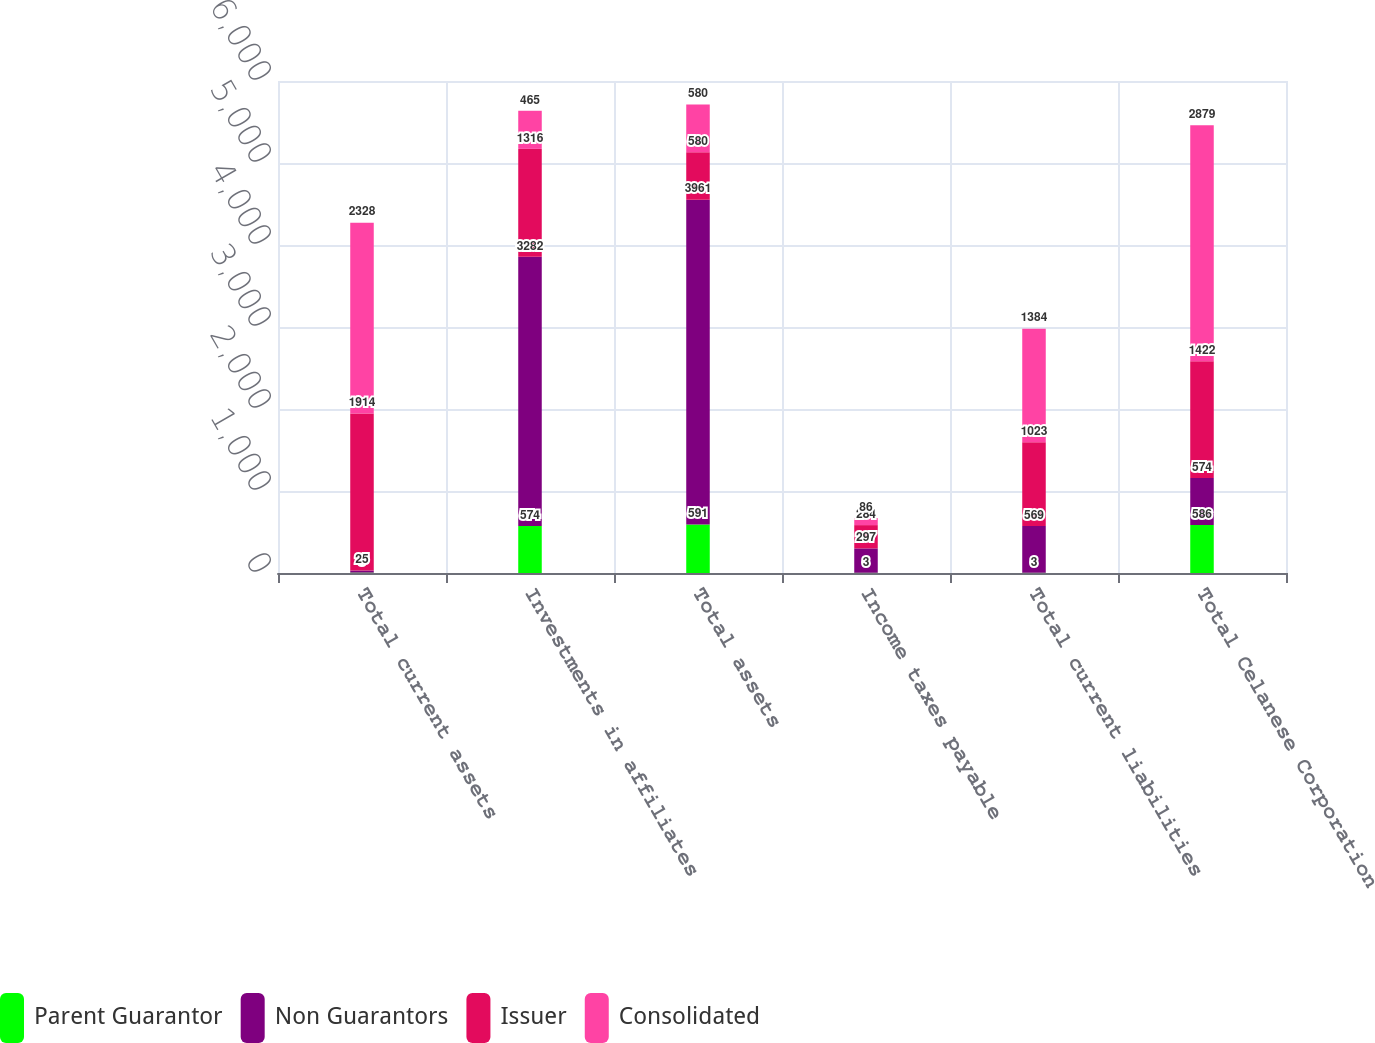<chart> <loc_0><loc_0><loc_500><loc_500><stacked_bar_chart><ecel><fcel>Total current assets<fcel>Investments in affiliates<fcel>Total assets<fcel>Income taxes payable<fcel>Total current liabilities<fcel>Total Celanese Corporation<nl><fcel>Parent Guarantor<fcel>5<fcel>574<fcel>591<fcel>3<fcel>3<fcel>586<nl><fcel>Non Guarantors<fcel>25<fcel>3282<fcel>3961<fcel>297<fcel>569<fcel>574<nl><fcel>Issuer<fcel>1914<fcel>1316<fcel>580<fcel>284<fcel>1023<fcel>1422<nl><fcel>Consolidated<fcel>2328<fcel>465<fcel>580<fcel>86<fcel>1384<fcel>2879<nl></chart> 